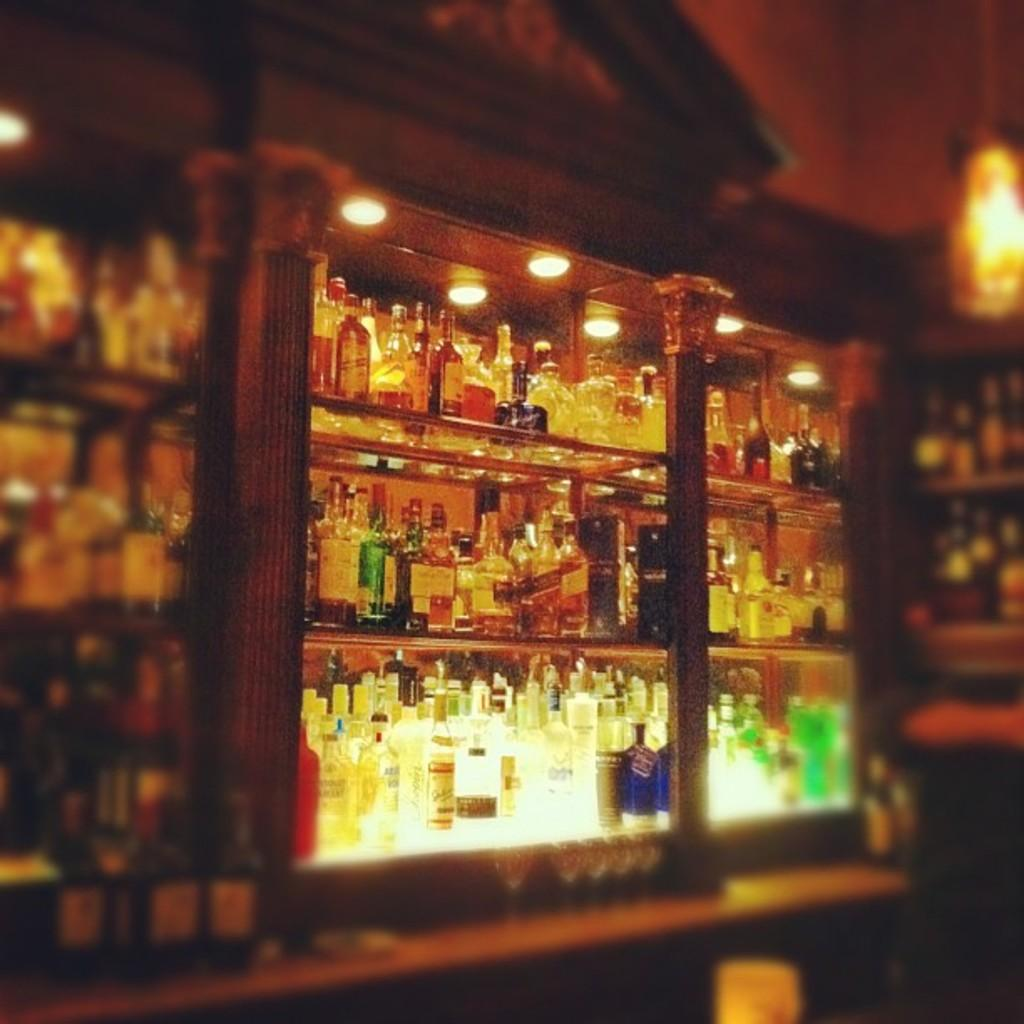What is the main subject of the image? The main subject of the image is a bar counter. What can be seen in the background of the image? There are wine bottles arranged in a shelf in the background. What else is visible in the image? Lights are visible in the image. Can you tell me how many crows are sitting on the bar counter in the image? There are no crows present in the image; it features a bar counter with wine bottles and lights. What type of cream is being used to decorate the wine bottles in the image? There is no cream present on the wine bottles or anywhere else in the image. 